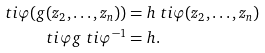Convert formula to latex. <formula><loc_0><loc_0><loc_500><loc_500>\ t i \varphi ( g ( z _ { 2 } , \dots , z _ { n } ) ) & = h \ t i \varphi ( z _ { 2 } , \dots , z _ { n } ) \\ \ t i \varphi g \ t i \varphi ^ { - 1 } & = h .</formula> 